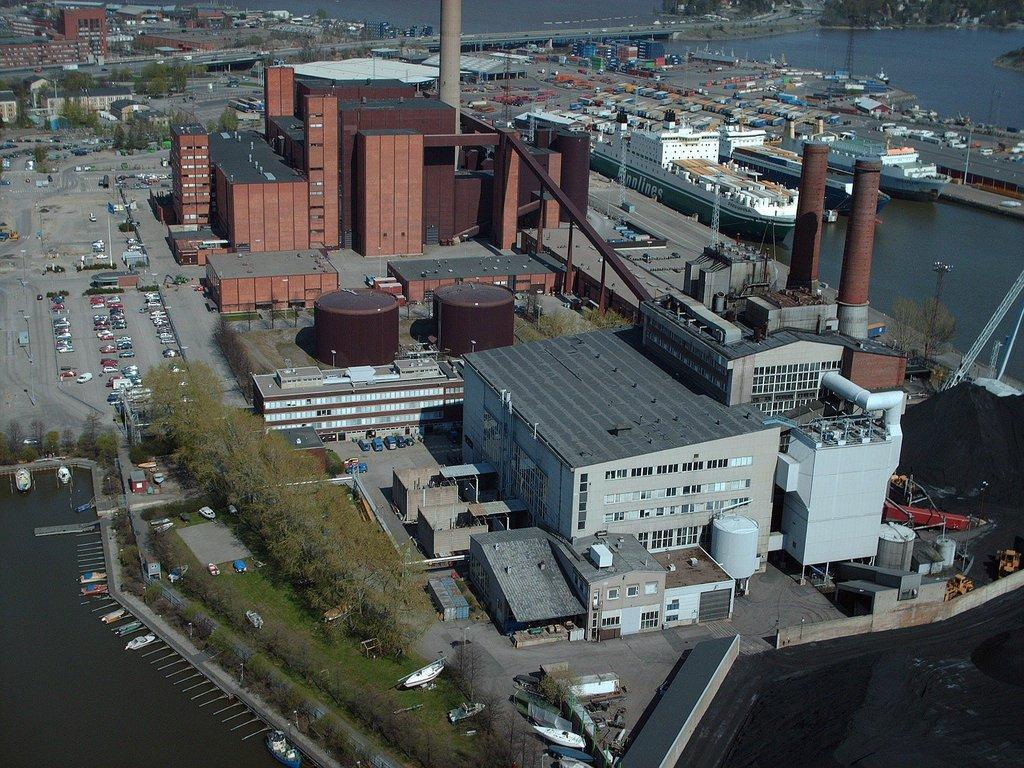Could you give a brief overview of what you see in this image? In this picture there are buildings in the center of the image, there are ships and buildings around the area of the image. 